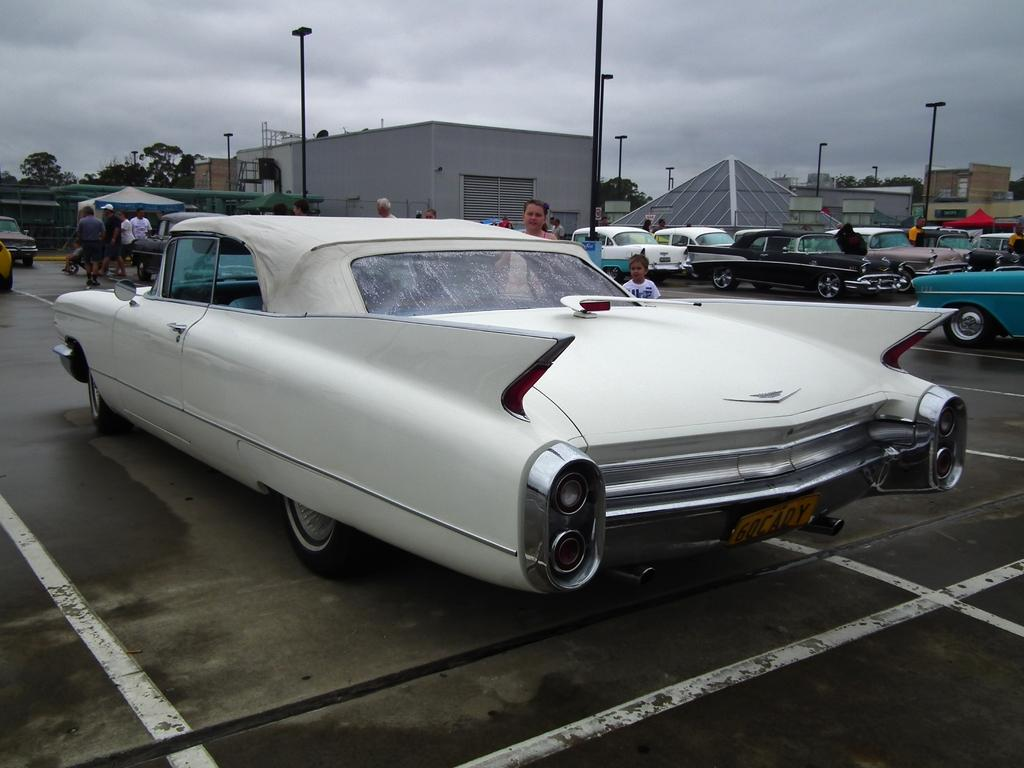What can be seen in the image that moves on roads or streets? There are vehicles in the image. What are the people in the image doing? There are people standing and walking in the image. What structures can be seen at the top of the image? There are tents, buildings, poles, and trees at the top of the image. What is visible in the sky at the top of the image? There are clouds and the sky visible at the top of the image. Can you tell me how many times the person in the image sneezes? There is no indication of anyone sneezing in the image. What type of lip balm is the person in the image using? There is no lip balm or any reference to lips in the image. 